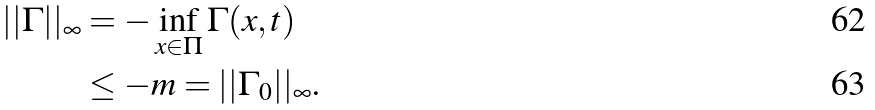Convert formula to latex. <formula><loc_0><loc_0><loc_500><loc_500>| | \Gamma | | _ { \infty } & = - \inf _ { x \in \Pi } \Gamma ( x , t ) \\ & \leq - m = | | \Gamma _ { 0 } | | _ { \infty } .</formula> 